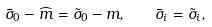Convert formula to latex. <formula><loc_0><loc_0><loc_500><loc_500>\bar { \sigma } _ { 0 } - \widehat { m } = \tilde { \sigma } _ { 0 } - m , \quad \bar { \sigma } _ { i } = \tilde { \sigma } _ { i } ,</formula> 